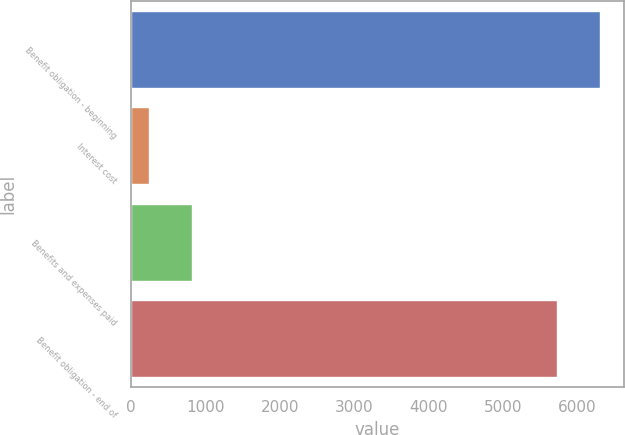Convert chart to OTSL. <chart><loc_0><loc_0><loc_500><loc_500><bar_chart><fcel>Benefit obligation - beginning<fcel>Interest cost<fcel>Benefits and expenses paid<fcel>Benefit obligation - end of<nl><fcel>6313<fcel>235<fcel>814<fcel>5734<nl></chart> 